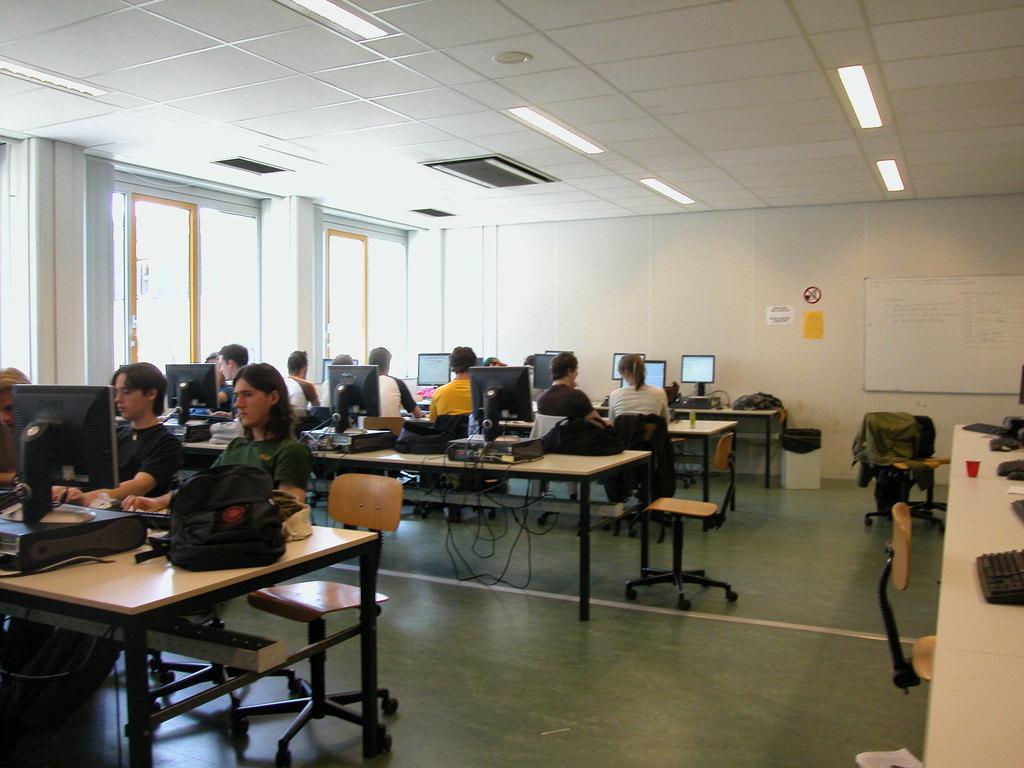How would you summarize this image in a sentence or two? In the image we can see few persons were sitting on the chair around the table. On table we can see monitor,backpack,mouse etc. In the background there is a wallboard,light,door,dustbin,chairs and table. 